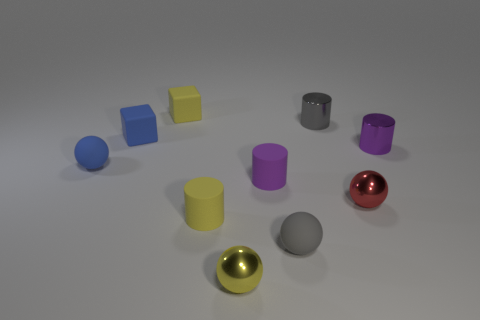There is a gray object that is in front of the sphere left of the tiny yellow sphere; how many small cylinders are in front of it?
Make the answer very short. 0. What number of objects are both in front of the tiny purple shiny cylinder and on the left side of the tiny red thing?
Provide a succinct answer. 5. Is the size of the yellow object behind the small purple metallic thing the same as the metal ball right of the gray cylinder?
Offer a terse response. Yes. What number of objects are small matte cylinders that are left of the yellow metallic sphere or blue metallic cubes?
Make the answer very short. 1. What is the material of the block right of the small blue rubber block?
Ensure brevity in your answer.  Rubber. What is the gray ball made of?
Give a very brief answer. Rubber. The small yellow thing behind the tiny cylinder that is left of the tiny shiny ball that is left of the red thing is made of what material?
Your answer should be very brief. Rubber. Is there any other thing that is the same material as the small red sphere?
Offer a terse response. Yes. There is a blue cube; is its size the same as the rubber cylinder that is left of the tiny yellow shiny object?
Offer a very short reply. Yes. What number of things are either rubber blocks on the left side of the yellow block or cylinders in front of the tiny gray cylinder?
Your response must be concise. 4. 